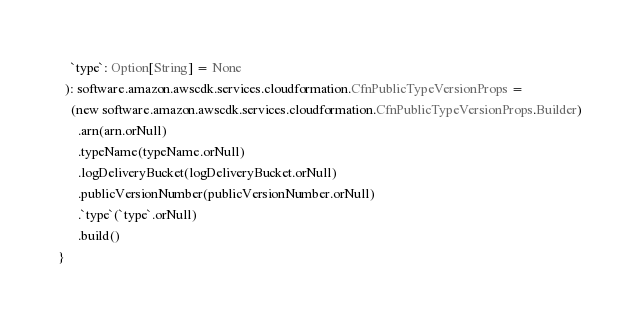<code> <loc_0><loc_0><loc_500><loc_500><_Scala_>    `type`: Option[String] = None
  ): software.amazon.awscdk.services.cloudformation.CfnPublicTypeVersionProps =
    (new software.amazon.awscdk.services.cloudformation.CfnPublicTypeVersionProps.Builder)
      .arn(arn.orNull)
      .typeName(typeName.orNull)
      .logDeliveryBucket(logDeliveryBucket.orNull)
      .publicVersionNumber(publicVersionNumber.orNull)
      .`type`(`type`.orNull)
      .build()
}
</code> 